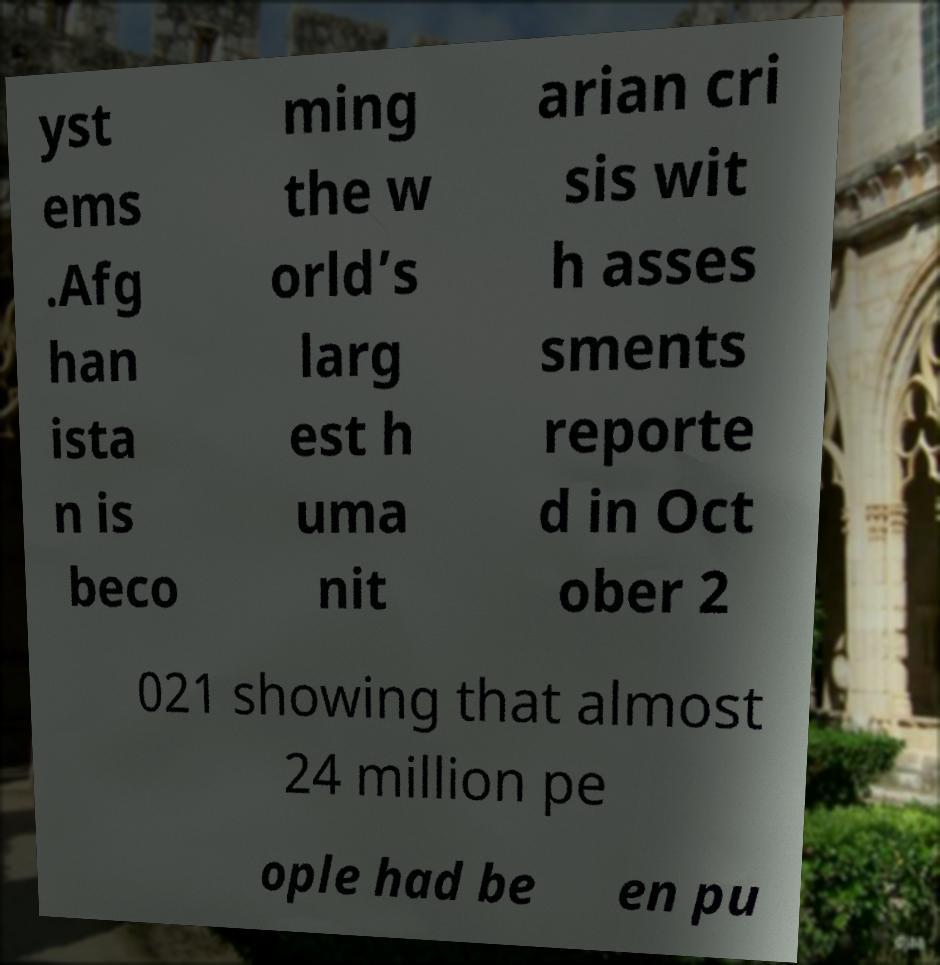Could you assist in decoding the text presented in this image and type it out clearly? yst ems .Afg han ista n is beco ming the w orld’s larg est h uma nit arian cri sis wit h asses sments reporte d in Oct ober 2 021 showing that almost 24 million pe ople had be en pu 